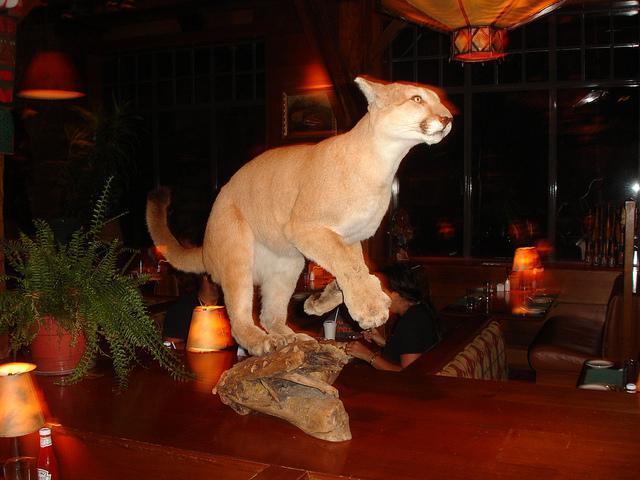How many people are there?
Give a very brief answer. 2. How many chairs are there?
Give a very brief answer. 2. How many horses are shown?
Give a very brief answer. 0. 